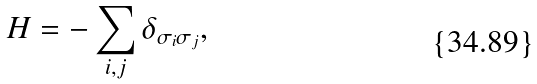Convert formula to latex. <formula><loc_0><loc_0><loc_500><loc_500>H = - \sum _ { i , j } \delta _ { \sigma _ { i } \sigma _ { j } } ,</formula> 